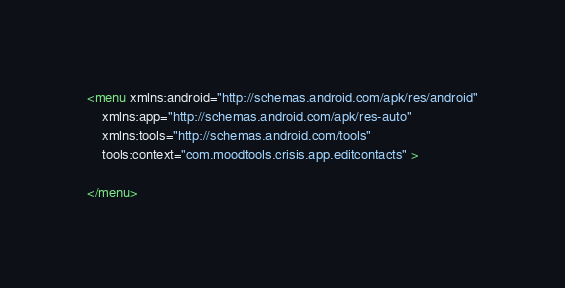Convert code to text. <code><loc_0><loc_0><loc_500><loc_500><_XML_><menu xmlns:android="http://schemas.android.com/apk/res/android"
    xmlns:app="http://schemas.android.com/apk/res-auto"
    xmlns:tools="http://schemas.android.com/tools"
    tools:context="com.moodtools.crisis.app.editcontacts" >

</menu>
</code> 